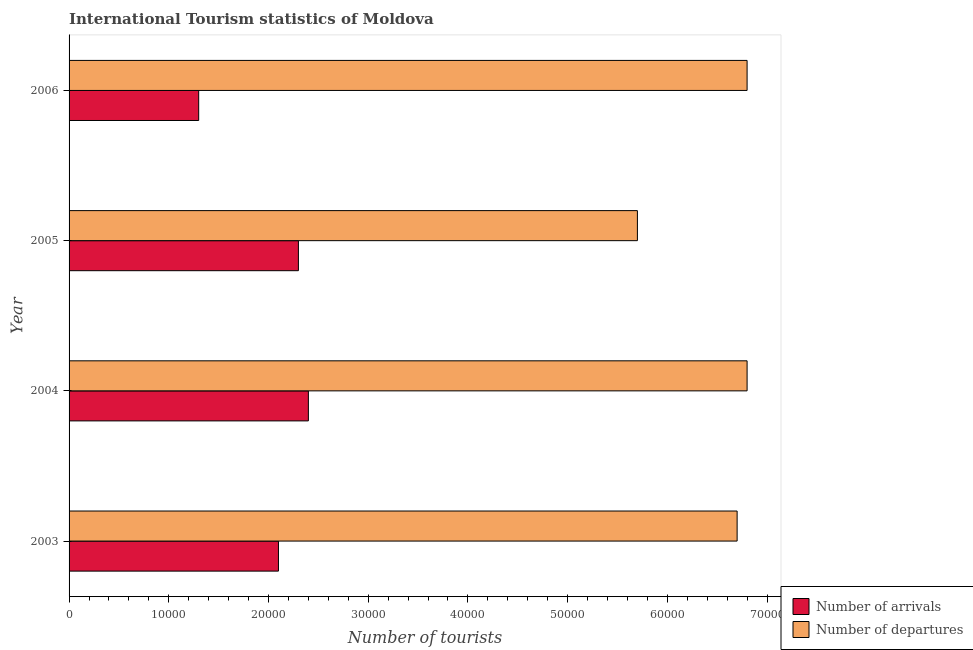How many different coloured bars are there?
Offer a very short reply. 2. Are the number of bars on each tick of the Y-axis equal?
Provide a short and direct response. Yes. How many bars are there on the 3rd tick from the top?
Give a very brief answer. 2. How many bars are there on the 3rd tick from the bottom?
Offer a terse response. 2. What is the label of the 4th group of bars from the top?
Your answer should be compact. 2003. What is the number of tourist departures in 2006?
Ensure brevity in your answer.  6.80e+04. Across all years, what is the maximum number of tourist departures?
Provide a succinct answer. 6.80e+04. Across all years, what is the minimum number of tourist departures?
Keep it short and to the point. 5.70e+04. In which year was the number of tourist departures minimum?
Provide a succinct answer. 2005. What is the total number of tourist arrivals in the graph?
Your answer should be compact. 8.10e+04. What is the difference between the number of tourist departures in 2004 and that in 2006?
Keep it short and to the point. 0. What is the difference between the number of tourist departures in 2005 and the number of tourist arrivals in 2003?
Keep it short and to the point. 3.60e+04. What is the average number of tourist arrivals per year?
Offer a terse response. 2.02e+04. In the year 2006, what is the difference between the number of tourist arrivals and number of tourist departures?
Your answer should be compact. -5.50e+04. In how many years, is the number of tourist departures greater than 48000 ?
Give a very brief answer. 4. What is the difference between the highest and the second highest number of tourist departures?
Offer a terse response. 0. What is the difference between the highest and the lowest number of tourist arrivals?
Your answer should be very brief. 1.10e+04. In how many years, is the number of tourist departures greater than the average number of tourist departures taken over all years?
Provide a short and direct response. 3. What does the 2nd bar from the top in 2004 represents?
Provide a succinct answer. Number of arrivals. What does the 1st bar from the bottom in 2004 represents?
Your answer should be compact. Number of arrivals. What is the difference between two consecutive major ticks on the X-axis?
Offer a very short reply. 10000. Are the values on the major ticks of X-axis written in scientific E-notation?
Ensure brevity in your answer.  No. Does the graph contain any zero values?
Offer a very short reply. No. Does the graph contain grids?
Your answer should be very brief. No. What is the title of the graph?
Provide a short and direct response. International Tourism statistics of Moldova. What is the label or title of the X-axis?
Offer a very short reply. Number of tourists. What is the Number of tourists in Number of arrivals in 2003?
Ensure brevity in your answer.  2.10e+04. What is the Number of tourists of Number of departures in 2003?
Make the answer very short. 6.70e+04. What is the Number of tourists of Number of arrivals in 2004?
Your response must be concise. 2.40e+04. What is the Number of tourists of Number of departures in 2004?
Provide a succinct answer. 6.80e+04. What is the Number of tourists in Number of arrivals in 2005?
Offer a very short reply. 2.30e+04. What is the Number of tourists of Number of departures in 2005?
Your answer should be very brief. 5.70e+04. What is the Number of tourists of Number of arrivals in 2006?
Your answer should be compact. 1.30e+04. What is the Number of tourists in Number of departures in 2006?
Give a very brief answer. 6.80e+04. Across all years, what is the maximum Number of tourists of Number of arrivals?
Ensure brevity in your answer.  2.40e+04. Across all years, what is the maximum Number of tourists in Number of departures?
Your answer should be compact. 6.80e+04. Across all years, what is the minimum Number of tourists of Number of arrivals?
Offer a terse response. 1.30e+04. Across all years, what is the minimum Number of tourists in Number of departures?
Ensure brevity in your answer.  5.70e+04. What is the total Number of tourists of Number of arrivals in the graph?
Your response must be concise. 8.10e+04. What is the total Number of tourists in Number of departures in the graph?
Your response must be concise. 2.60e+05. What is the difference between the Number of tourists of Number of arrivals in 2003 and that in 2004?
Give a very brief answer. -3000. What is the difference between the Number of tourists in Number of departures in 2003 and that in 2004?
Make the answer very short. -1000. What is the difference between the Number of tourists in Number of arrivals in 2003 and that in 2005?
Make the answer very short. -2000. What is the difference between the Number of tourists in Number of arrivals in 2003 and that in 2006?
Provide a short and direct response. 8000. What is the difference between the Number of tourists of Number of departures in 2003 and that in 2006?
Offer a very short reply. -1000. What is the difference between the Number of tourists of Number of arrivals in 2004 and that in 2005?
Your answer should be very brief. 1000. What is the difference between the Number of tourists in Number of departures in 2004 and that in 2005?
Your response must be concise. 1.10e+04. What is the difference between the Number of tourists of Number of arrivals in 2004 and that in 2006?
Offer a very short reply. 1.10e+04. What is the difference between the Number of tourists in Number of arrivals in 2005 and that in 2006?
Offer a very short reply. 10000. What is the difference between the Number of tourists in Number of departures in 2005 and that in 2006?
Your answer should be compact. -1.10e+04. What is the difference between the Number of tourists of Number of arrivals in 2003 and the Number of tourists of Number of departures in 2004?
Your answer should be very brief. -4.70e+04. What is the difference between the Number of tourists in Number of arrivals in 2003 and the Number of tourists in Number of departures in 2005?
Keep it short and to the point. -3.60e+04. What is the difference between the Number of tourists of Number of arrivals in 2003 and the Number of tourists of Number of departures in 2006?
Offer a very short reply. -4.70e+04. What is the difference between the Number of tourists in Number of arrivals in 2004 and the Number of tourists in Number of departures in 2005?
Make the answer very short. -3.30e+04. What is the difference between the Number of tourists in Number of arrivals in 2004 and the Number of tourists in Number of departures in 2006?
Keep it short and to the point. -4.40e+04. What is the difference between the Number of tourists of Number of arrivals in 2005 and the Number of tourists of Number of departures in 2006?
Offer a terse response. -4.50e+04. What is the average Number of tourists in Number of arrivals per year?
Keep it short and to the point. 2.02e+04. What is the average Number of tourists of Number of departures per year?
Your response must be concise. 6.50e+04. In the year 2003, what is the difference between the Number of tourists in Number of arrivals and Number of tourists in Number of departures?
Your answer should be compact. -4.60e+04. In the year 2004, what is the difference between the Number of tourists in Number of arrivals and Number of tourists in Number of departures?
Offer a terse response. -4.40e+04. In the year 2005, what is the difference between the Number of tourists in Number of arrivals and Number of tourists in Number of departures?
Make the answer very short. -3.40e+04. In the year 2006, what is the difference between the Number of tourists of Number of arrivals and Number of tourists of Number of departures?
Keep it short and to the point. -5.50e+04. What is the ratio of the Number of tourists of Number of departures in 2003 to that in 2005?
Provide a succinct answer. 1.18. What is the ratio of the Number of tourists of Number of arrivals in 2003 to that in 2006?
Ensure brevity in your answer.  1.62. What is the ratio of the Number of tourists of Number of arrivals in 2004 to that in 2005?
Offer a terse response. 1.04. What is the ratio of the Number of tourists of Number of departures in 2004 to that in 2005?
Ensure brevity in your answer.  1.19. What is the ratio of the Number of tourists of Number of arrivals in 2004 to that in 2006?
Ensure brevity in your answer.  1.85. What is the ratio of the Number of tourists of Number of departures in 2004 to that in 2006?
Your response must be concise. 1. What is the ratio of the Number of tourists of Number of arrivals in 2005 to that in 2006?
Offer a terse response. 1.77. What is the ratio of the Number of tourists of Number of departures in 2005 to that in 2006?
Your answer should be very brief. 0.84. What is the difference between the highest and the lowest Number of tourists in Number of arrivals?
Keep it short and to the point. 1.10e+04. What is the difference between the highest and the lowest Number of tourists in Number of departures?
Ensure brevity in your answer.  1.10e+04. 